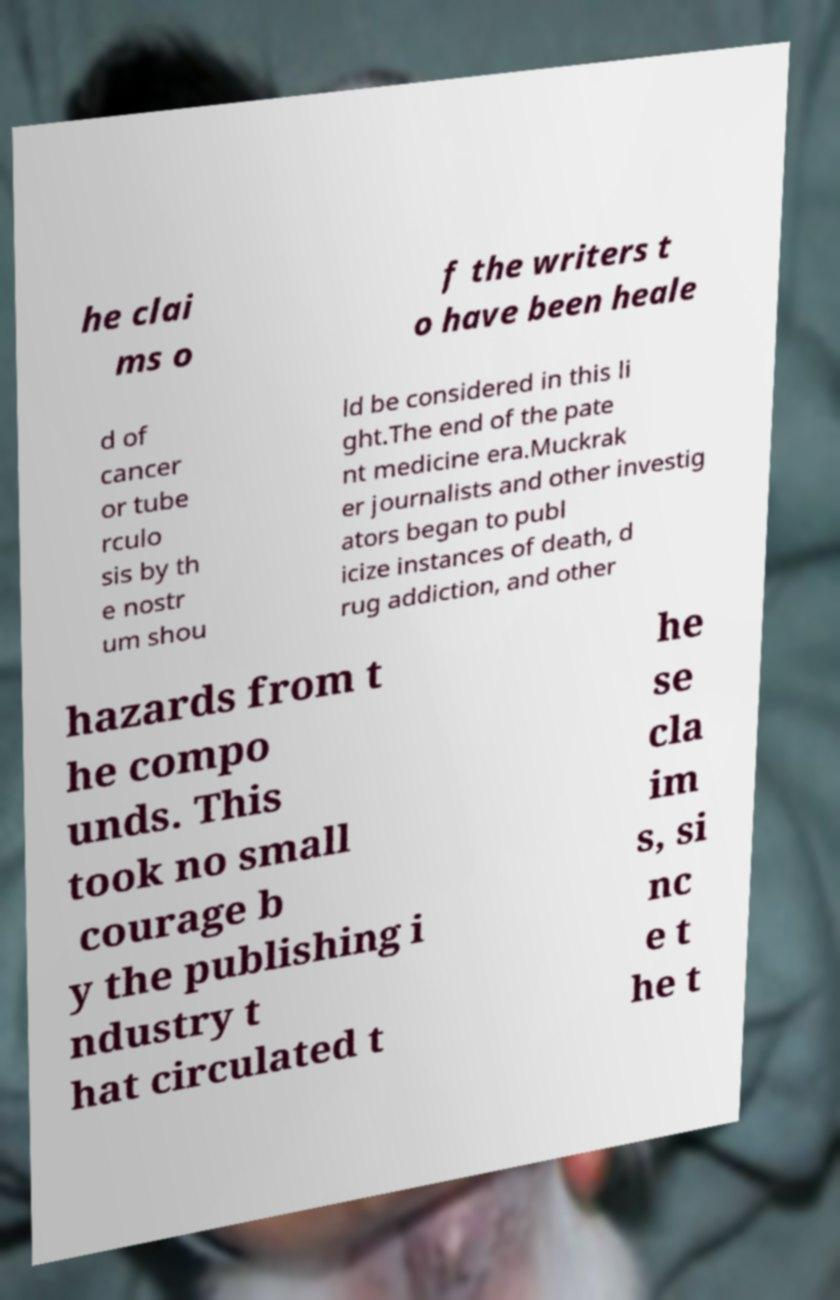Please read and relay the text visible in this image. What does it say? he clai ms o f the writers t o have been heale d of cancer or tube rculo sis by th e nostr um shou ld be considered in this li ght.The end of the pate nt medicine era.Muckrak er journalists and other investig ators began to publ icize instances of death, d rug addiction, and other hazards from t he compo unds. This took no small courage b y the publishing i ndustry t hat circulated t he se cla im s, si nc e t he t 